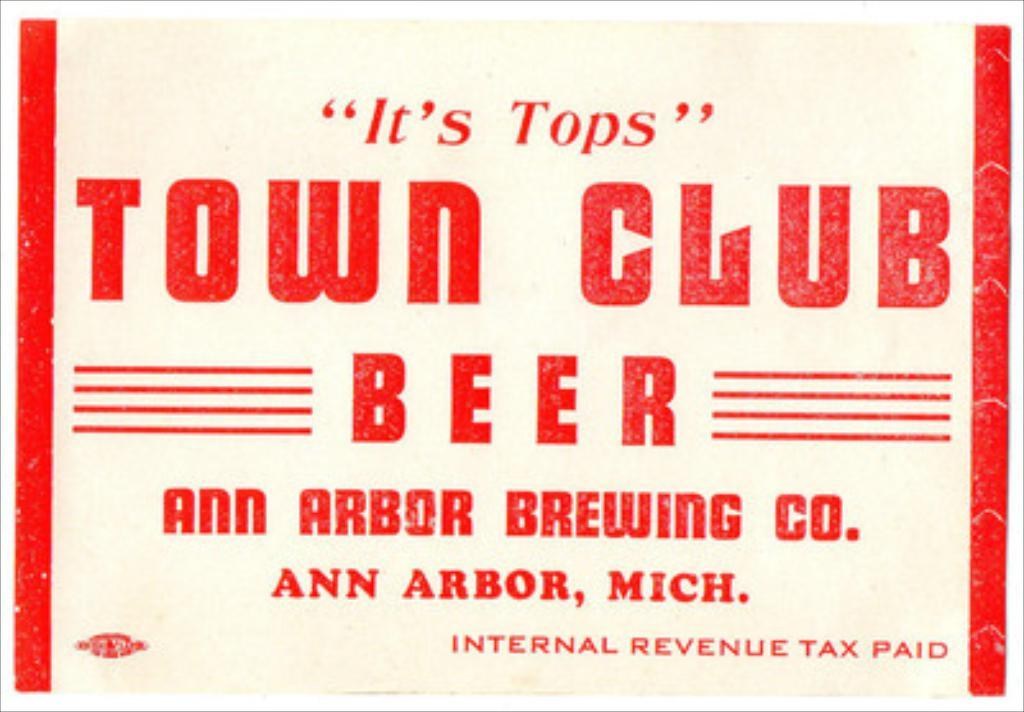<image>
Present a compact description of the photo's key features. A red and white advertisement for the Town Club Beer Company. 